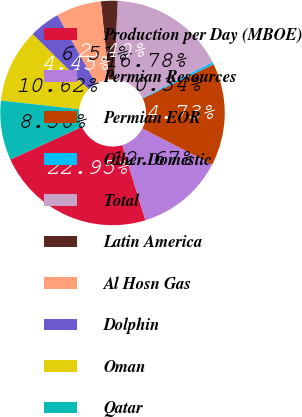Convert chart. <chart><loc_0><loc_0><loc_500><loc_500><pie_chart><fcel>Production per Day (MBOE)<fcel>Permian Resources<fcel>Permian EOR<fcel>Other Domestic<fcel>Total<fcel>Latin America<fcel>Al Hosn Gas<fcel>Dolphin<fcel>Oman<fcel>Qatar<nl><fcel>22.95%<fcel>12.67%<fcel>14.73%<fcel>0.34%<fcel>16.78%<fcel>2.4%<fcel>6.51%<fcel>4.45%<fcel>10.62%<fcel>8.56%<nl></chart> 